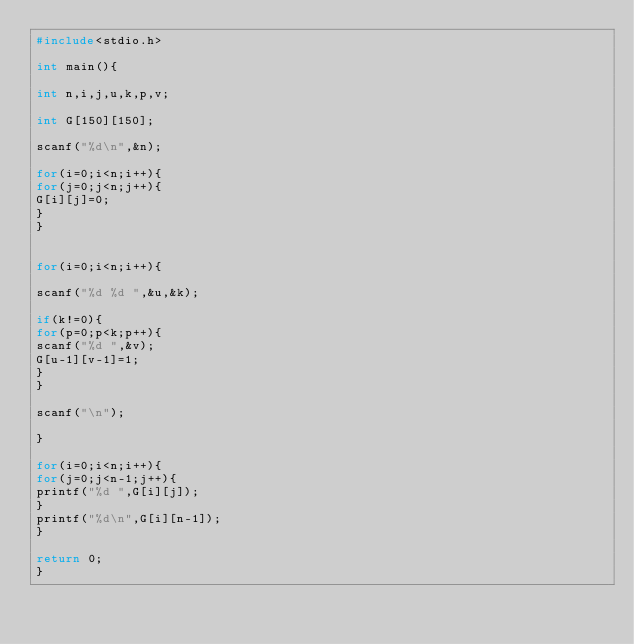<code> <loc_0><loc_0><loc_500><loc_500><_C_>#include<stdio.h>

int main(){

int n,i,j,u,k,p,v;

int G[150][150];

scanf("%d\n",&n);

for(i=0;i<n;i++){
for(j=0;j<n;j++){
G[i][j]=0;
}
}


for(i=0;i<n;i++){

scanf("%d %d ",&u,&k);

if(k!=0){
for(p=0;p<k;p++){
scanf("%d ",&v);
G[u-1][v-1]=1;
}
}

scanf("\n");

}

for(i=0;i<n;i++){
for(j=0;j<n-1;j++){
printf("%d ",G[i][j]);
}
printf("%d\n",G[i][n-1]);
}

return 0;
}




</code> 